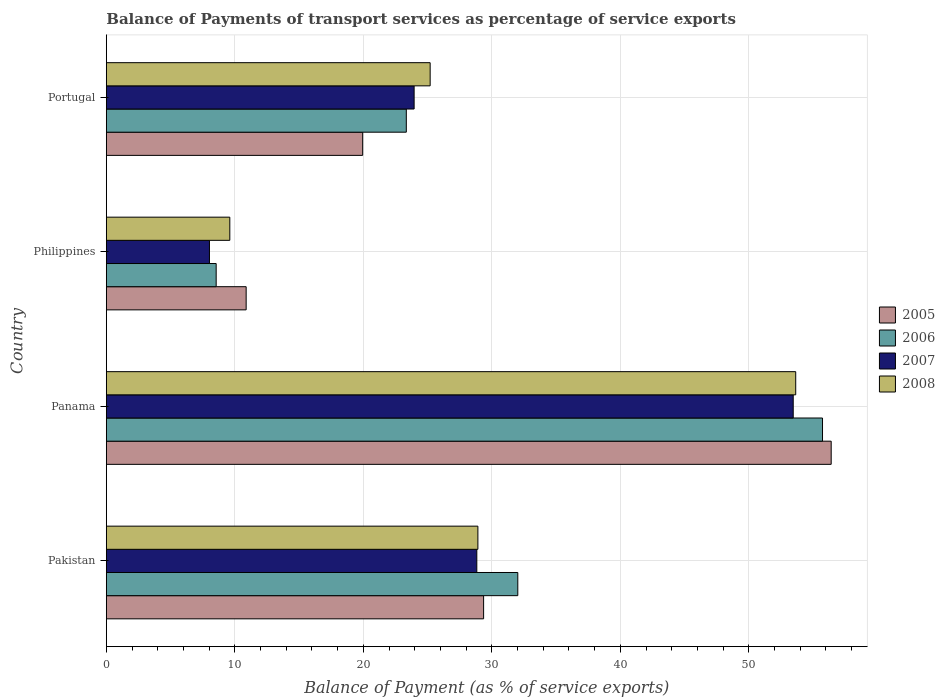How many different coloured bars are there?
Give a very brief answer. 4. How many groups of bars are there?
Your answer should be compact. 4. Are the number of bars per tick equal to the number of legend labels?
Offer a very short reply. Yes. Are the number of bars on each tick of the Y-axis equal?
Keep it short and to the point. Yes. How many bars are there on the 2nd tick from the top?
Offer a terse response. 4. How many bars are there on the 3rd tick from the bottom?
Make the answer very short. 4. What is the label of the 1st group of bars from the top?
Make the answer very short. Portugal. What is the balance of payments of transport services in 2005 in Panama?
Offer a very short reply. 56.41. Across all countries, what is the maximum balance of payments of transport services in 2007?
Your answer should be very brief. 53.45. Across all countries, what is the minimum balance of payments of transport services in 2006?
Provide a short and direct response. 8.55. In which country was the balance of payments of transport services in 2006 maximum?
Make the answer very short. Panama. What is the total balance of payments of transport services in 2007 in the graph?
Offer a very short reply. 114.26. What is the difference between the balance of payments of transport services in 2005 in Pakistan and that in Philippines?
Provide a short and direct response. 18.48. What is the difference between the balance of payments of transport services in 2006 in Portugal and the balance of payments of transport services in 2005 in Philippines?
Provide a succinct answer. 12.46. What is the average balance of payments of transport services in 2007 per country?
Your response must be concise. 28.57. What is the difference between the balance of payments of transport services in 2006 and balance of payments of transport services in 2007 in Portugal?
Your answer should be very brief. -0.61. In how many countries, is the balance of payments of transport services in 2007 greater than 24 %?
Keep it short and to the point. 2. What is the ratio of the balance of payments of transport services in 2008 in Panama to that in Philippines?
Offer a very short reply. 5.58. Is the balance of payments of transport services in 2005 in Panama less than that in Philippines?
Ensure brevity in your answer.  No. Is the difference between the balance of payments of transport services in 2006 in Pakistan and Philippines greater than the difference between the balance of payments of transport services in 2007 in Pakistan and Philippines?
Ensure brevity in your answer.  Yes. What is the difference between the highest and the second highest balance of payments of transport services in 2008?
Keep it short and to the point. 24.73. What is the difference between the highest and the lowest balance of payments of transport services in 2005?
Provide a succinct answer. 45.53. What does the 4th bar from the bottom in Philippines represents?
Ensure brevity in your answer.  2008. How many bars are there?
Provide a short and direct response. 16. How many countries are there in the graph?
Provide a succinct answer. 4. What is the difference between two consecutive major ticks on the X-axis?
Ensure brevity in your answer.  10. Are the values on the major ticks of X-axis written in scientific E-notation?
Offer a very short reply. No. How are the legend labels stacked?
Keep it short and to the point. Vertical. What is the title of the graph?
Offer a terse response. Balance of Payments of transport services as percentage of service exports. Does "1973" appear as one of the legend labels in the graph?
Give a very brief answer. No. What is the label or title of the X-axis?
Keep it short and to the point. Balance of Payment (as % of service exports). What is the Balance of Payment (as % of service exports) of 2005 in Pakistan?
Give a very brief answer. 29.36. What is the Balance of Payment (as % of service exports) in 2006 in Pakistan?
Your answer should be compact. 32.02. What is the Balance of Payment (as % of service exports) in 2007 in Pakistan?
Your answer should be very brief. 28.83. What is the Balance of Payment (as % of service exports) in 2008 in Pakistan?
Your response must be concise. 28.91. What is the Balance of Payment (as % of service exports) in 2005 in Panama?
Make the answer very short. 56.41. What is the Balance of Payment (as % of service exports) in 2006 in Panama?
Offer a very short reply. 55.73. What is the Balance of Payment (as % of service exports) in 2007 in Panama?
Make the answer very short. 53.45. What is the Balance of Payment (as % of service exports) in 2008 in Panama?
Make the answer very short. 53.65. What is the Balance of Payment (as % of service exports) in 2005 in Philippines?
Keep it short and to the point. 10.88. What is the Balance of Payment (as % of service exports) in 2006 in Philippines?
Make the answer very short. 8.55. What is the Balance of Payment (as % of service exports) of 2007 in Philippines?
Your answer should be very brief. 8.02. What is the Balance of Payment (as % of service exports) of 2008 in Philippines?
Your answer should be very brief. 9.61. What is the Balance of Payment (as % of service exports) of 2005 in Portugal?
Provide a short and direct response. 19.95. What is the Balance of Payment (as % of service exports) in 2006 in Portugal?
Offer a terse response. 23.34. What is the Balance of Payment (as % of service exports) in 2007 in Portugal?
Offer a terse response. 23.95. What is the Balance of Payment (as % of service exports) of 2008 in Portugal?
Offer a very short reply. 25.2. Across all countries, what is the maximum Balance of Payment (as % of service exports) in 2005?
Offer a terse response. 56.41. Across all countries, what is the maximum Balance of Payment (as % of service exports) of 2006?
Give a very brief answer. 55.73. Across all countries, what is the maximum Balance of Payment (as % of service exports) of 2007?
Make the answer very short. 53.45. Across all countries, what is the maximum Balance of Payment (as % of service exports) of 2008?
Your answer should be compact. 53.65. Across all countries, what is the minimum Balance of Payment (as % of service exports) in 2005?
Offer a very short reply. 10.88. Across all countries, what is the minimum Balance of Payment (as % of service exports) of 2006?
Give a very brief answer. 8.55. Across all countries, what is the minimum Balance of Payment (as % of service exports) of 2007?
Your response must be concise. 8.02. Across all countries, what is the minimum Balance of Payment (as % of service exports) of 2008?
Provide a succinct answer. 9.61. What is the total Balance of Payment (as % of service exports) in 2005 in the graph?
Offer a terse response. 116.6. What is the total Balance of Payment (as % of service exports) of 2006 in the graph?
Keep it short and to the point. 119.64. What is the total Balance of Payment (as % of service exports) in 2007 in the graph?
Offer a terse response. 114.26. What is the total Balance of Payment (as % of service exports) in 2008 in the graph?
Provide a short and direct response. 117.37. What is the difference between the Balance of Payment (as % of service exports) in 2005 in Pakistan and that in Panama?
Offer a very short reply. -27.05. What is the difference between the Balance of Payment (as % of service exports) in 2006 in Pakistan and that in Panama?
Provide a succinct answer. -23.71. What is the difference between the Balance of Payment (as % of service exports) of 2007 in Pakistan and that in Panama?
Give a very brief answer. -24.62. What is the difference between the Balance of Payment (as % of service exports) in 2008 in Pakistan and that in Panama?
Provide a succinct answer. -24.73. What is the difference between the Balance of Payment (as % of service exports) of 2005 in Pakistan and that in Philippines?
Your answer should be very brief. 18.48. What is the difference between the Balance of Payment (as % of service exports) in 2006 in Pakistan and that in Philippines?
Make the answer very short. 23.47. What is the difference between the Balance of Payment (as % of service exports) of 2007 in Pakistan and that in Philippines?
Give a very brief answer. 20.81. What is the difference between the Balance of Payment (as % of service exports) of 2008 in Pakistan and that in Philippines?
Ensure brevity in your answer.  19.31. What is the difference between the Balance of Payment (as % of service exports) in 2005 in Pakistan and that in Portugal?
Provide a short and direct response. 9.41. What is the difference between the Balance of Payment (as % of service exports) of 2006 in Pakistan and that in Portugal?
Keep it short and to the point. 8.68. What is the difference between the Balance of Payment (as % of service exports) of 2007 in Pakistan and that in Portugal?
Provide a short and direct response. 4.88. What is the difference between the Balance of Payment (as % of service exports) in 2008 in Pakistan and that in Portugal?
Ensure brevity in your answer.  3.71. What is the difference between the Balance of Payment (as % of service exports) in 2005 in Panama and that in Philippines?
Your answer should be compact. 45.53. What is the difference between the Balance of Payment (as % of service exports) of 2006 in Panama and that in Philippines?
Offer a very short reply. 47.19. What is the difference between the Balance of Payment (as % of service exports) of 2007 in Panama and that in Philippines?
Offer a very short reply. 45.43. What is the difference between the Balance of Payment (as % of service exports) in 2008 in Panama and that in Philippines?
Your answer should be compact. 44.04. What is the difference between the Balance of Payment (as % of service exports) of 2005 in Panama and that in Portugal?
Ensure brevity in your answer.  36.46. What is the difference between the Balance of Payment (as % of service exports) of 2006 in Panama and that in Portugal?
Keep it short and to the point. 32.39. What is the difference between the Balance of Payment (as % of service exports) of 2007 in Panama and that in Portugal?
Provide a succinct answer. 29.5. What is the difference between the Balance of Payment (as % of service exports) of 2008 in Panama and that in Portugal?
Provide a succinct answer. 28.45. What is the difference between the Balance of Payment (as % of service exports) in 2005 in Philippines and that in Portugal?
Give a very brief answer. -9.07. What is the difference between the Balance of Payment (as % of service exports) of 2006 in Philippines and that in Portugal?
Keep it short and to the point. -14.8. What is the difference between the Balance of Payment (as % of service exports) of 2007 in Philippines and that in Portugal?
Provide a short and direct response. -15.93. What is the difference between the Balance of Payment (as % of service exports) of 2008 in Philippines and that in Portugal?
Keep it short and to the point. -15.59. What is the difference between the Balance of Payment (as % of service exports) of 2005 in Pakistan and the Balance of Payment (as % of service exports) of 2006 in Panama?
Offer a terse response. -26.37. What is the difference between the Balance of Payment (as % of service exports) in 2005 in Pakistan and the Balance of Payment (as % of service exports) in 2007 in Panama?
Your answer should be very brief. -24.09. What is the difference between the Balance of Payment (as % of service exports) in 2005 in Pakistan and the Balance of Payment (as % of service exports) in 2008 in Panama?
Give a very brief answer. -24.29. What is the difference between the Balance of Payment (as % of service exports) of 2006 in Pakistan and the Balance of Payment (as % of service exports) of 2007 in Panama?
Your answer should be compact. -21.43. What is the difference between the Balance of Payment (as % of service exports) in 2006 in Pakistan and the Balance of Payment (as % of service exports) in 2008 in Panama?
Provide a succinct answer. -21.63. What is the difference between the Balance of Payment (as % of service exports) of 2007 in Pakistan and the Balance of Payment (as % of service exports) of 2008 in Panama?
Keep it short and to the point. -24.82. What is the difference between the Balance of Payment (as % of service exports) in 2005 in Pakistan and the Balance of Payment (as % of service exports) in 2006 in Philippines?
Provide a short and direct response. 20.81. What is the difference between the Balance of Payment (as % of service exports) in 2005 in Pakistan and the Balance of Payment (as % of service exports) in 2007 in Philippines?
Offer a very short reply. 21.33. What is the difference between the Balance of Payment (as % of service exports) of 2005 in Pakistan and the Balance of Payment (as % of service exports) of 2008 in Philippines?
Your response must be concise. 19.75. What is the difference between the Balance of Payment (as % of service exports) of 2006 in Pakistan and the Balance of Payment (as % of service exports) of 2007 in Philippines?
Keep it short and to the point. 24. What is the difference between the Balance of Payment (as % of service exports) in 2006 in Pakistan and the Balance of Payment (as % of service exports) in 2008 in Philippines?
Provide a short and direct response. 22.41. What is the difference between the Balance of Payment (as % of service exports) in 2007 in Pakistan and the Balance of Payment (as % of service exports) in 2008 in Philippines?
Your response must be concise. 19.22. What is the difference between the Balance of Payment (as % of service exports) of 2005 in Pakistan and the Balance of Payment (as % of service exports) of 2006 in Portugal?
Your answer should be very brief. 6.02. What is the difference between the Balance of Payment (as % of service exports) of 2005 in Pakistan and the Balance of Payment (as % of service exports) of 2007 in Portugal?
Offer a very short reply. 5.41. What is the difference between the Balance of Payment (as % of service exports) in 2005 in Pakistan and the Balance of Payment (as % of service exports) in 2008 in Portugal?
Provide a short and direct response. 4.16. What is the difference between the Balance of Payment (as % of service exports) of 2006 in Pakistan and the Balance of Payment (as % of service exports) of 2007 in Portugal?
Offer a terse response. 8.07. What is the difference between the Balance of Payment (as % of service exports) in 2006 in Pakistan and the Balance of Payment (as % of service exports) in 2008 in Portugal?
Your answer should be very brief. 6.82. What is the difference between the Balance of Payment (as % of service exports) in 2007 in Pakistan and the Balance of Payment (as % of service exports) in 2008 in Portugal?
Ensure brevity in your answer.  3.63. What is the difference between the Balance of Payment (as % of service exports) of 2005 in Panama and the Balance of Payment (as % of service exports) of 2006 in Philippines?
Offer a very short reply. 47.86. What is the difference between the Balance of Payment (as % of service exports) in 2005 in Panama and the Balance of Payment (as % of service exports) in 2007 in Philippines?
Provide a succinct answer. 48.38. What is the difference between the Balance of Payment (as % of service exports) in 2005 in Panama and the Balance of Payment (as % of service exports) in 2008 in Philippines?
Offer a very short reply. 46.8. What is the difference between the Balance of Payment (as % of service exports) in 2006 in Panama and the Balance of Payment (as % of service exports) in 2007 in Philippines?
Provide a short and direct response. 47.71. What is the difference between the Balance of Payment (as % of service exports) in 2006 in Panama and the Balance of Payment (as % of service exports) in 2008 in Philippines?
Your answer should be compact. 46.12. What is the difference between the Balance of Payment (as % of service exports) of 2007 in Panama and the Balance of Payment (as % of service exports) of 2008 in Philippines?
Offer a very short reply. 43.84. What is the difference between the Balance of Payment (as % of service exports) of 2005 in Panama and the Balance of Payment (as % of service exports) of 2006 in Portugal?
Provide a short and direct response. 33.06. What is the difference between the Balance of Payment (as % of service exports) in 2005 in Panama and the Balance of Payment (as % of service exports) in 2007 in Portugal?
Provide a succinct answer. 32.46. What is the difference between the Balance of Payment (as % of service exports) in 2005 in Panama and the Balance of Payment (as % of service exports) in 2008 in Portugal?
Make the answer very short. 31.21. What is the difference between the Balance of Payment (as % of service exports) of 2006 in Panama and the Balance of Payment (as % of service exports) of 2007 in Portugal?
Your answer should be compact. 31.78. What is the difference between the Balance of Payment (as % of service exports) of 2006 in Panama and the Balance of Payment (as % of service exports) of 2008 in Portugal?
Your answer should be compact. 30.53. What is the difference between the Balance of Payment (as % of service exports) of 2007 in Panama and the Balance of Payment (as % of service exports) of 2008 in Portugal?
Keep it short and to the point. 28.25. What is the difference between the Balance of Payment (as % of service exports) in 2005 in Philippines and the Balance of Payment (as % of service exports) in 2006 in Portugal?
Provide a short and direct response. -12.46. What is the difference between the Balance of Payment (as % of service exports) of 2005 in Philippines and the Balance of Payment (as % of service exports) of 2007 in Portugal?
Ensure brevity in your answer.  -13.07. What is the difference between the Balance of Payment (as % of service exports) in 2005 in Philippines and the Balance of Payment (as % of service exports) in 2008 in Portugal?
Make the answer very short. -14.32. What is the difference between the Balance of Payment (as % of service exports) of 2006 in Philippines and the Balance of Payment (as % of service exports) of 2007 in Portugal?
Ensure brevity in your answer.  -15.4. What is the difference between the Balance of Payment (as % of service exports) in 2006 in Philippines and the Balance of Payment (as % of service exports) in 2008 in Portugal?
Provide a succinct answer. -16.65. What is the difference between the Balance of Payment (as % of service exports) of 2007 in Philippines and the Balance of Payment (as % of service exports) of 2008 in Portugal?
Offer a terse response. -17.18. What is the average Balance of Payment (as % of service exports) of 2005 per country?
Provide a succinct answer. 29.15. What is the average Balance of Payment (as % of service exports) in 2006 per country?
Your answer should be very brief. 29.91. What is the average Balance of Payment (as % of service exports) in 2007 per country?
Provide a short and direct response. 28.57. What is the average Balance of Payment (as % of service exports) in 2008 per country?
Give a very brief answer. 29.34. What is the difference between the Balance of Payment (as % of service exports) in 2005 and Balance of Payment (as % of service exports) in 2006 in Pakistan?
Give a very brief answer. -2.66. What is the difference between the Balance of Payment (as % of service exports) in 2005 and Balance of Payment (as % of service exports) in 2007 in Pakistan?
Ensure brevity in your answer.  0.53. What is the difference between the Balance of Payment (as % of service exports) in 2005 and Balance of Payment (as % of service exports) in 2008 in Pakistan?
Provide a succinct answer. 0.44. What is the difference between the Balance of Payment (as % of service exports) in 2006 and Balance of Payment (as % of service exports) in 2007 in Pakistan?
Make the answer very short. 3.19. What is the difference between the Balance of Payment (as % of service exports) in 2006 and Balance of Payment (as % of service exports) in 2008 in Pakistan?
Your response must be concise. 3.1. What is the difference between the Balance of Payment (as % of service exports) of 2007 and Balance of Payment (as % of service exports) of 2008 in Pakistan?
Offer a very short reply. -0.08. What is the difference between the Balance of Payment (as % of service exports) of 2005 and Balance of Payment (as % of service exports) of 2006 in Panama?
Your answer should be compact. 0.67. What is the difference between the Balance of Payment (as % of service exports) of 2005 and Balance of Payment (as % of service exports) of 2007 in Panama?
Make the answer very short. 2.95. What is the difference between the Balance of Payment (as % of service exports) in 2005 and Balance of Payment (as % of service exports) in 2008 in Panama?
Offer a terse response. 2.76. What is the difference between the Balance of Payment (as % of service exports) in 2006 and Balance of Payment (as % of service exports) in 2007 in Panama?
Provide a succinct answer. 2.28. What is the difference between the Balance of Payment (as % of service exports) of 2006 and Balance of Payment (as % of service exports) of 2008 in Panama?
Provide a succinct answer. 2.09. What is the difference between the Balance of Payment (as % of service exports) of 2007 and Balance of Payment (as % of service exports) of 2008 in Panama?
Give a very brief answer. -0.19. What is the difference between the Balance of Payment (as % of service exports) of 2005 and Balance of Payment (as % of service exports) of 2006 in Philippines?
Offer a very short reply. 2.33. What is the difference between the Balance of Payment (as % of service exports) of 2005 and Balance of Payment (as % of service exports) of 2007 in Philippines?
Offer a very short reply. 2.86. What is the difference between the Balance of Payment (as % of service exports) in 2005 and Balance of Payment (as % of service exports) in 2008 in Philippines?
Keep it short and to the point. 1.27. What is the difference between the Balance of Payment (as % of service exports) in 2006 and Balance of Payment (as % of service exports) in 2007 in Philippines?
Keep it short and to the point. 0.52. What is the difference between the Balance of Payment (as % of service exports) of 2006 and Balance of Payment (as % of service exports) of 2008 in Philippines?
Give a very brief answer. -1.06. What is the difference between the Balance of Payment (as % of service exports) in 2007 and Balance of Payment (as % of service exports) in 2008 in Philippines?
Make the answer very short. -1.58. What is the difference between the Balance of Payment (as % of service exports) in 2005 and Balance of Payment (as % of service exports) in 2006 in Portugal?
Keep it short and to the point. -3.4. What is the difference between the Balance of Payment (as % of service exports) of 2005 and Balance of Payment (as % of service exports) of 2007 in Portugal?
Your answer should be very brief. -4. What is the difference between the Balance of Payment (as % of service exports) in 2005 and Balance of Payment (as % of service exports) in 2008 in Portugal?
Offer a very short reply. -5.25. What is the difference between the Balance of Payment (as % of service exports) of 2006 and Balance of Payment (as % of service exports) of 2007 in Portugal?
Give a very brief answer. -0.61. What is the difference between the Balance of Payment (as % of service exports) in 2006 and Balance of Payment (as % of service exports) in 2008 in Portugal?
Provide a short and direct response. -1.86. What is the difference between the Balance of Payment (as % of service exports) in 2007 and Balance of Payment (as % of service exports) in 2008 in Portugal?
Your answer should be very brief. -1.25. What is the ratio of the Balance of Payment (as % of service exports) in 2005 in Pakistan to that in Panama?
Give a very brief answer. 0.52. What is the ratio of the Balance of Payment (as % of service exports) of 2006 in Pakistan to that in Panama?
Offer a terse response. 0.57. What is the ratio of the Balance of Payment (as % of service exports) of 2007 in Pakistan to that in Panama?
Provide a short and direct response. 0.54. What is the ratio of the Balance of Payment (as % of service exports) in 2008 in Pakistan to that in Panama?
Your answer should be compact. 0.54. What is the ratio of the Balance of Payment (as % of service exports) in 2005 in Pakistan to that in Philippines?
Provide a short and direct response. 2.7. What is the ratio of the Balance of Payment (as % of service exports) in 2006 in Pakistan to that in Philippines?
Keep it short and to the point. 3.75. What is the ratio of the Balance of Payment (as % of service exports) in 2007 in Pakistan to that in Philippines?
Provide a short and direct response. 3.59. What is the ratio of the Balance of Payment (as % of service exports) of 2008 in Pakistan to that in Philippines?
Make the answer very short. 3.01. What is the ratio of the Balance of Payment (as % of service exports) of 2005 in Pakistan to that in Portugal?
Your answer should be very brief. 1.47. What is the ratio of the Balance of Payment (as % of service exports) in 2006 in Pakistan to that in Portugal?
Provide a short and direct response. 1.37. What is the ratio of the Balance of Payment (as % of service exports) in 2007 in Pakistan to that in Portugal?
Provide a succinct answer. 1.2. What is the ratio of the Balance of Payment (as % of service exports) in 2008 in Pakistan to that in Portugal?
Give a very brief answer. 1.15. What is the ratio of the Balance of Payment (as % of service exports) in 2005 in Panama to that in Philippines?
Offer a very short reply. 5.18. What is the ratio of the Balance of Payment (as % of service exports) of 2006 in Panama to that in Philippines?
Offer a terse response. 6.52. What is the ratio of the Balance of Payment (as % of service exports) of 2007 in Panama to that in Philippines?
Keep it short and to the point. 6.66. What is the ratio of the Balance of Payment (as % of service exports) of 2008 in Panama to that in Philippines?
Your answer should be compact. 5.58. What is the ratio of the Balance of Payment (as % of service exports) of 2005 in Panama to that in Portugal?
Your answer should be compact. 2.83. What is the ratio of the Balance of Payment (as % of service exports) in 2006 in Panama to that in Portugal?
Offer a very short reply. 2.39. What is the ratio of the Balance of Payment (as % of service exports) in 2007 in Panama to that in Portugal?
Provide a succinct answer. 2.23. What is the ratio of the Balance of Payment (as % of service exports) in 2008 in Panama to that in Portugal?
Your answer should be very brief. 2.13. What is the ratio of the Balance of Payment (as % of service exports) of 2005 in Philippines to that in Portugal?
Ensure brevity in your answer.  0.55. What is the ratio of the Balance of Payment (as % of service exports) in 2006 in Philippines to that in Portugal?
Keep it short and to the point. 0.37. What is the ratio of the Balance of Payment (as % of service exports) in 2007 in Philippines to that in Portugal?
Your answer should be very brief. 0.34. What is the ratio of the Balance of Payment (as % of service exports) in 2008 in Philippines to that in Portugal?
Your answer should be compact. 0.38. What is the difference between the highest and the second highest Balance of Payment (as % of service exports) in 2005?
Give a very brief answer. 27.05. What is the difference between the highest and the second highest Balance of Payment (as % of service exports) of 2006?
Your response must be concise. 23.71. What is the difference between the highest and the second highest Balance of Payment (as % of service exports) in 2007?
Your response must be concise. 24.62. What is the difference between the highest and the second highest Balance of Payment (as % of service exports) of 2008?
Provide a succinct answer. 24.73. What is the difference between the highest and the lowest Balance of Payment (as % of service exports) of 2005?
Offer a very short reply. 45.53. What is the difference between the highest and the lowest Balance of Payment (as % of service exports) of 2006?
Keep it short and to the point. 47.19. What is the difference between the highest and the lowest Balance of Payment (as % of service exports) in 2007?
Provide a succinct answer. 45.43. What is the difference between the highest and the lowest Balance of Payment (as % of service exports) of 2008?
Offer a terse response. 44.04. 